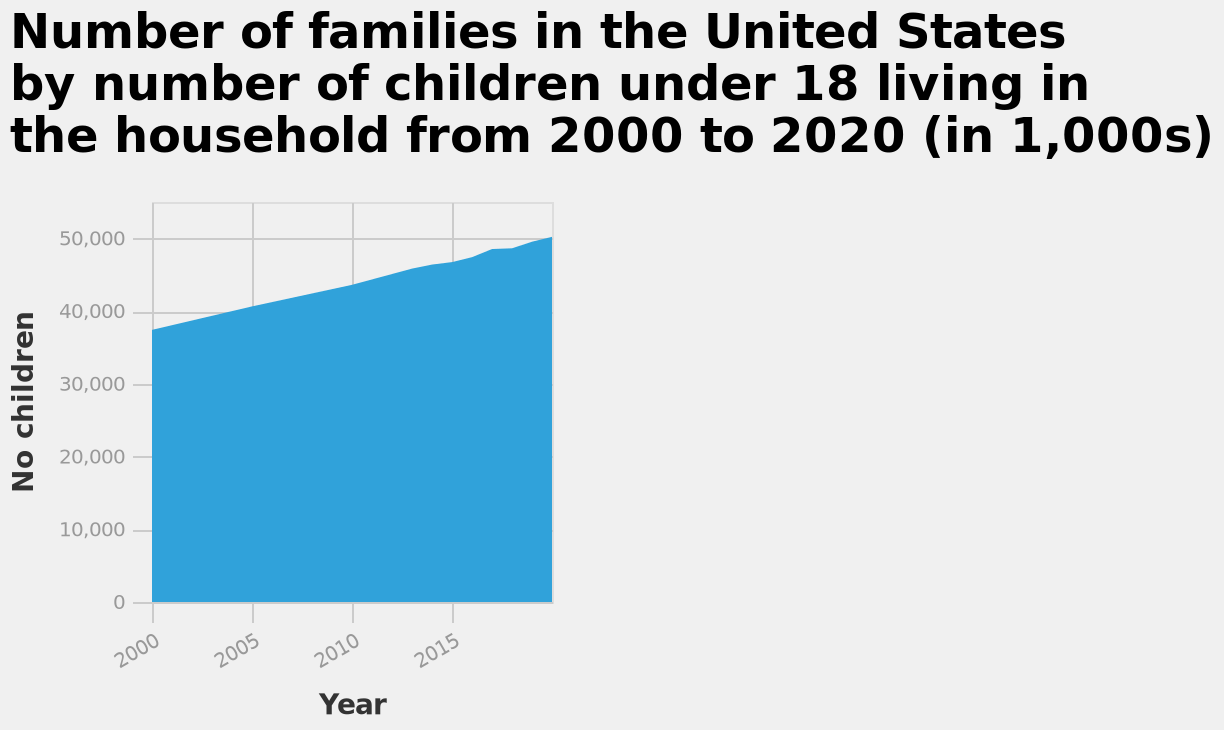<image>
How many families in the United States had no children in their household in the year 2000? According to the area diagram, in the year 2000, there were approximately 59,000 families in the United States with no children in their household. What is the trend of the number of US families with children under 18 living in the household since the year 2000? The trend of the number of US families with children under 18 living in the household since the year 2000 has been a steady increase. In which year did the United States have the highest number of families with no children? According to the area diagram, the United States had the highest number of families with no children in the year 2005, with approximately 63,000 such families. What was the trend in the number of families with no children in the United States from 2000 to 2020? The area diagram shows that the number of families with no children in the United States remained relatively constant from 2000 to 2020, hovering around 59,000. 